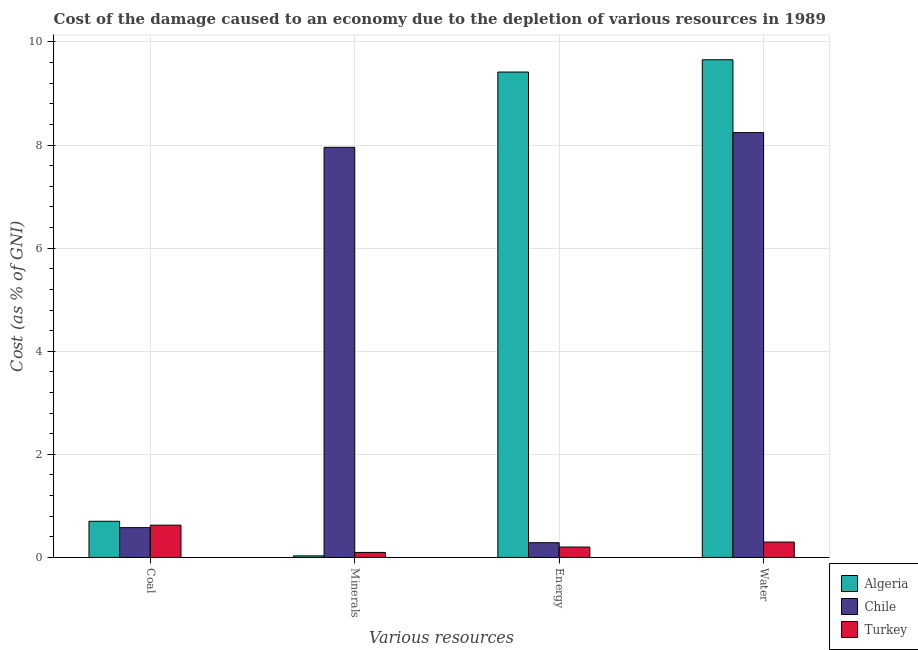How many different coloured bars are there?
Your response must be concise. 3. How many groups of bars are there?
Make the answer very short. 4. Are the number of bars per tick equal to the number of legend labels?
Provide a short and direct response. Yes. How many bars are there on the 2nd tick from the left?
Provide a short and direct response. 3. What is the label of the 3rd group of bars from the left?
Provide a succinct answer. Energy. What is the cost of damage due to depletion of water in Turkey?
Your response must be concise. 0.3. Across all countries, what is the maximum cost of damage due to depletion of water?
Make the answer very short. 9.66. Across all countries, what is the minimum cost of damage due to depletion of minerals?
Your response must be concise. 0.03. In which country was the cost of damage due to depletion of energy maximum?
Make the answer very short. Algeria. In which country was the cost of damage due to depletion of minerals minimum?
Offer a very short reply. Algeria. What is the total cost of damage due to depletion of energy in the graph?
Offer a very short reply. 9.9. What is the difference between the cost of damage due to depletion of minerals in Chile and that in Turkey?
Your response must be concise. 7.86. What is the difference between the cost of damage due to depletion of water in Turkey and the cost of damage due to depletion of coal in Chile?
Provide a short and direct response. -0.28. What is the average cost of damage due to depletion of water per country?
Your answer should be very brief. 6.06. What is the difference between the cost of damage due to depletion of coal and cost of damage due to depletion of water in Turkey?
Keep it short and to the point. 0.33. In how many countries, is the cost of damage due to depletion of energy greater than 6.8 %?
Your answer should be compact. 1. What is the ratio of the cost of damage due to depletion of minerals in Algeria to that in Turkey?
Keep it short and to the point. 0.31. What is the difference between the highest and the second highest cost of damage due to depletion of water?
Offer a terse response. 1.41. What is the difference between the highest and the lowest cost of damage due to depletion of energy?
Make the answer very short. 9.22. What does the 2nd bar from the left in Energy represents?
Ensure brevity in your answer.  Chile. Is it the case that in every country, the sum of the cost of damage due to depletion of coal and cost of damage due to depletion of minerals is greater than the cost of damage due to depletion of energy?
Give a very brief answer. No. Are all the bars in the graph horizontal?
Your answer should be very brief. No. How many countries are there in the graph?
Provide a succinct answer. 3. What is the difference between two consecutive major ticks on the Y-axis?
Give a very brief answer. 2. Does the graph contain any zero values?
Provide a short and direct response. No. What is the title of the graph?
Your answer should be very brief. Cost of the damage caused to an economy due to the depletion of various resources in 1989 . Does "Kosovo" appear as one of the legend labels in the graph?
Your answer should be very brief. No. What is the label or title of the X-axis?
Offer a terse response. Various resources. What is the label or title of the Y-axis?
Provide a succinct answer. Cost (as % of GNI). What is the Cost (as % of GNI) of Algeria in Coal?
Make the answer very short. 0.7. What is the Cost (as % of GNI) of Chile in Coal?
Your answer should be compact. 0.58. What is the Cost (as % of GNI) in Turkey in Coal?
Your answer should be compact. 0.63. What is the Cost (as % of GNI) in Algeria in Minerals?
Keep it short and to the point. 0.03. What is the Cost (as % of GNI) in Chile in Minerals?
Keep it short and to the point. 7.96. What is the Cost (as % of GNI) of Turkey in Minerals?
Your answer should be compact. 0.1. What is the Cost (as % of GNI) of Algeria in Energy?
Your response must be concise. 9.42. What is the Cost (as % of GNI) of Chile in Energy?
Offer a very short reply. 0.29. What is the Cost (as % of GNI) of Turkey in Energy?
Provide a succinct answer. 0.2. What is the Cost (as % of GNI) in Algeria in Water?
Make the answer very short. 9.66. What is the Cost (as % of GNI) in Chile in Water?
Your response must be concise. 8.24. What is the Cost (as % of GNI) in Turkey in Water?
Provide a succinct answer. 0.3. Across all Various resources, what is the maximum Cost (as % of GNI) in Algeria?
Your answer should be very brief. 9.66. Across all Various resources, what is the maximum Cost (as % of GNI) in Chile?
Ensure brevity in your answer.  8.24. Across all Various resources, what is the maximum Cost (as % of GNI) in Turkey?
Offer a terse response. 0.63. Across all Various resources, what is the minimum Cost (as % of GNI) of Algeria?
Your answer should be compact. 0.03. Across all Various resources, what is the minimum Cost (as % of GNI) of Chile?
Your response must be concise. 0.29. Across all Various resources, what is the minimum Cost (as % of GNI) in Turkey?
Ensure brevity in your answer.  0.1. What is the total Cost (as % of GNI) of Algeria in the graph?
Offer a very short reply. 19.8. What is the total Cost (as % of GNI) in Chile in the graph?
Offer a terse response. 17.06. What is the total Cost (as % of GNI) in Turkey in the graph?
Your answer should be very brief. 1.22. What is the difference between the Cost (as % of GNI) of Algeria in Coal and that in Minerals?
Your response must be concise. 0.67. What is the difference between the Cost (as % of GNI) of Chile in Coal and that in Minerals?
Your answer should be very brief. -7.38. What is the difference between the Cost (as % of GNI) in Turkey in Coal and that in Minerals?
Offer a very short reply. 0.53. What is the difference between the Cost (as % of GNI) in Algeria in Coal and that in Energy?
Provide a short and direct response. -8.72. What is the difference between the Cost (as % of GNI) of Chile in Coal and that in Energy?
Offer a very short reply. 0.29. What is the difference between the Cost (as % of GNI) in Turkey in Coal and that in Energy?
Offer a very short reply. 0.42. What is the difference between the Cost (as % of GNI) of Algeria in Coal and that in Water?
Your answer should be very brief. -8.95. What is the difference between the Cost (as % of GNI) in Chile in Coal and that in Water?
Provide a short and direct response. -7.66. What is the difference between the Cost (as % of GNI) in Turkey in Coal and that in Water?
Provide a short and direct response. 0.33. What is the difference between the Cost (as % of GNI) in Algeria in Minerals and that in Energy?
Provide a succinct answer. -9.39. What is the difference between the Cost (as % of GNI) in Chile in Minerals and that in Energy?
Ensure brevity in your answer.  7.67. What is the difference between the Cost (as % of GNI) of Turkey in Minerals and that in Energy?
Give a very brief answer. -0.1. What is the difference between the Cost (as % of GNI) in Algeria in Minerals and that in Water?
Keep it short and to the point. -9.62. What is the difference between the Cost (as % of GNI) in Chile in Minerals and that in Water?
Your answer should be very brief. -0.29. What is the difference between the Cost (as % of GNI) of Turkey in Minerals and that in Water?
Ensure brevity in your answer.  -0.2. What is the difference between the Cost (as % of GNI) of Algeria in Energy and that in Water?
Offer a terse response. -0.24. What is the difference between the Cost (as % of GNI) of Chile in Energy and that in Water?
Provide a short and direct response. -7.96. What is the difference between the Cost (as % of GNI) in Turkey in Energy and that in Water?
Keep it short and to the point. -0.1. What is the difference between the Cost (as % of GNI) in Algeria in Coal and the Cost (as % of GNI) in Chile in Minerals?
Your response must be concise. -7.25. What is the difference between the Cost (as % of GNI) of Algeria in Coal and the Cost (as % of GNI) of Turkey in Minerals?
Provide a succinct answer. 0.6. What is the difference between the Cost (as % of GNI) of Chile in Coal and the Cost (as % of GNI) of Turkey in Minerals?
Offer a terse response. 0.48. What is the difference between the Cost (as % of GNI) in Algeria in Coal and the Cost (as % of GNI) in Chile in Energy?
Ensure brevity in your answer.  0.42. What is the difference between the Cost (as % of GNI) of Algeria in Coal and the Cost (as % of GNI) of Turkey in Energy?
Your response must be concise. 0.5. What is the difference between the Cost (as % of GNI) of Chile in Coal and the Cost (as % of GNI) of Turkey in Energy?
Offer a terse response. 0.38. What is the difference between the Cost (as % of GNI) in Algeria in Coal and the Cost (as % of GNI) in Chile in Water?
Ensure brevity in your answer.  -7.54. What is the difference between the Cost (as % of GNI) in Algeria in Coal and the Cost (as % of GNI) in Turkey in Water?
Your answer should be very brief. 0.4. What is the difference between the Cost (as % of GNI) of Chile in Coal and the Cost (as % of GNI) of Turkey in Water?
Provide a succinct answer. 0.28. What is the difference between the Cost (as % of GNI) of Algeria in Minerals and the Cost (as % of GNI) of Chile in Energy?
Give a very brief answer. -0.26. What is the difference between the Cost (as % of GNI) of Algeria in Minerals and the Cost (as % of GNI) of Turkey in Energy?
Offer a terse response. -0.17. What is the difference between the Cost (as % of GNI) of Chile in Minerals and the Cost (as % of GNI) of Turkey in Energy?
Your answer should be very brief. 7.75. What is the difference between the Cost (as % of GNI) in Algeria in Minerals and the Cost (as % of GNI) in Chile in Water?
Your answer should be compact. -8.21. What is the difference between the Cost (as % of GNI) in Algeria in Minerals and the Cost (as % of GNI) in Turkey in Water?
Keep it short and to the point. -0.27. What is the difference between the Cost (as % of GNI) of Chile in Minerals and the Cost (as % of GNI) of Turkey in Water?
Offer a terse response. 7.66. What is the difference between the Cost (as % of GNI) in Algeria in Energy and the Cost (as % of GNI) in Chile in Water?
Your answer should be very brief. 1.18. What is the difference between the Cost (as % of GNI) of Algeria in Energy and the Cost (as % of GNI) of Turkey in Water?
Your answer should be very brief. 9.12. What is the difference between the Cost (as % of GNI) of Chile in Energy and the Cost (as % of GNI) of Turkey in Water?
Make the answer very short. -0.01. What is the average Cost (as % of GNI) in Algeria per Various resources?
Your response must be concise. 4.95. What is the average Cost (as % of GNI) of Chile per Various resources?
Offer a very short reply. 4.27. What is the average Cost (as % of GNI) of Turkey per Various resources?
Keep it short and to the point. 0.31. What is the difference between the Cost (as % of GNI) in Algeria and Cost (as % of GNI) in Chile in Coal?
Give a very brief answer. 0.12. What is the difference between the Cost (as % of GNI) of Algeria and Cost (as % of GNI) of Turkey in Coal?
Offer a terse response. 0.08. What is the difference between the Cost (as % of GNI) of Chile and Cost (as % of GNI) of Turkey in Coal?
Make the answer very short. -0.05. What is the difference between the Cost (as % of GNI) of Algeria and Cost (as % of GNI) of Chile in Minerals?
Keep it short and to the point. -7.93. What is the difference between the Cost (as % of GNI) in Algeria and Cost (as % of GNI) in Turkey in Minerals?
Ensure brevity in your answer.  -0.07. What is the difference between the Cost (as % of GNI) in Chile and Cost (as % of GNI) in Turkey in Minerals?
Give a very brief answer. 7.86. What is the difference between the Cost (as % of GNI) in Algeria and Cost (as % of GNI) in Chile in Energy?
Your answer should be very brief. 9.13. What is the difference between the Cost (as % of GNI) of Algeria and Cost (as % of GNI) of Turkey in Energy?
Your response must be concise. 9.22. What is the difference between the Cost (as % of GNI) in Chile and Cost (as % of GNI) in Turkey in Energy?
Make the answer very short. 0.08. What is the difference between the Cost (as % of GNI) of Algeria and Cost (as % of GNI) of Chile in Water?
Give a very brief answer. 1.41. What is the difference between the Cost (as % of GNI) of Algeria and Cost (as % of GNI) of Turkey in Water?
Make the answer very short. 9.36. What is the difference between the Cost (as % of GNI) in Chile and Cost (as % of GNI) in Turkey in Water?
Make the answer very short. 7.94. What is the ratio of the Cost (as % of GNI) in Algeria in Coal to that in Minerals?
Offer a terse response. 23.25. What is the ratio of the Cost (as % of GNI) in Chile in Coal to that in Minerals?
Make the answer very short. 0.07. What is the ratio of the Cost (as % of GNI) in Turkey in Coal to that in Minerals?
Your answer should be compact. 6.45. What is the ratio of the Cost (as % of GNI) of Algeria in Coal to that in Energy?
Make the answer very short. 0.07. What is the ratio of the Cost (as % of GNI) of Chile in Coal to that in Energy?
Provide a succinct answer. 2.02. What is the ratio of the Cost (as % of GNI) of Turkey in Coal to that in Energy?
Make the answer very short. 3.11. What is the ratio of the Cost (as % of GNI) in Algeria in Coal to that in Water?
Offer a very short reply. 0.07. What is the ratio of the Cost (as % of GNI) in Chile in Coal to that in Water?
Give a very brief answer. 0.07. What is the ratio of the Cost (as % of GNI) of Turkey in Coal to that in Water?
Offer a very short reply. 2.1. What is the ratio of the Cost (as % of GNI) of Algeria in Minerals to that in Energy?
Provide a short and direct response. 0. What is the ratio of the Cost (as % of GNI) in Chile in Minerals to that in Energy?
Keep it short and to the point. 27.86. What is the ratio of the Cost (as % of GNI) in Turkey in Minerals to that in Energy?
Provide a succinct answer. 0.48. What is the ratio of the Cost (as % of GNI) in Algeria in Minerals to that in Water?
Ensure brevity in your answer.  0. What is the ratio of the Cost (as % of GNI) of Chile in Minerals to that in Water?
Offer a very short reply. 0.97. What is the ratio of the Cost (as % of GNI) in Turkey in Minerals to that in Water?
Your response must be concise. 0.33. What is the ratio of the Cost (as % of GNI) of Algeria in Energy to that in Water?
Your answer should be compact. 0.98. What is the ratio of the Cost (as % of GNI) in Chile in Energy to that in Water?
Provide a succinct answer. 0.03. What is the ratio of the Cost (as % of GNI) of Turkey in Energy to that in Water?
Your answer should be compact. 0.67. What is the difference between the highest and the second highest Cost (as % of GNI) of Algeria?
Offer a terse response. 0.24. What is the difference between the highest and the second highest Cost (as % of GNI) in Chile?
Your response must be concise. 0.29. What is the difference between the highest and the second highest Cost (as % of GNI) in Turkey?
Provide a short and direct response. 0.33. What is the difference between the highest and the lowest Cost (as % of GNI) in Algeria?
Give a very brief answer. 9.62. What is the difference between the highest and the lowest Cost (as % of GNI) of Chile?
Provide a succinct answer. 7.96. What is the difference between the highest and the lowest Cost (as % of GNI) in Turkey?
Offer a terse response. 0.53. 